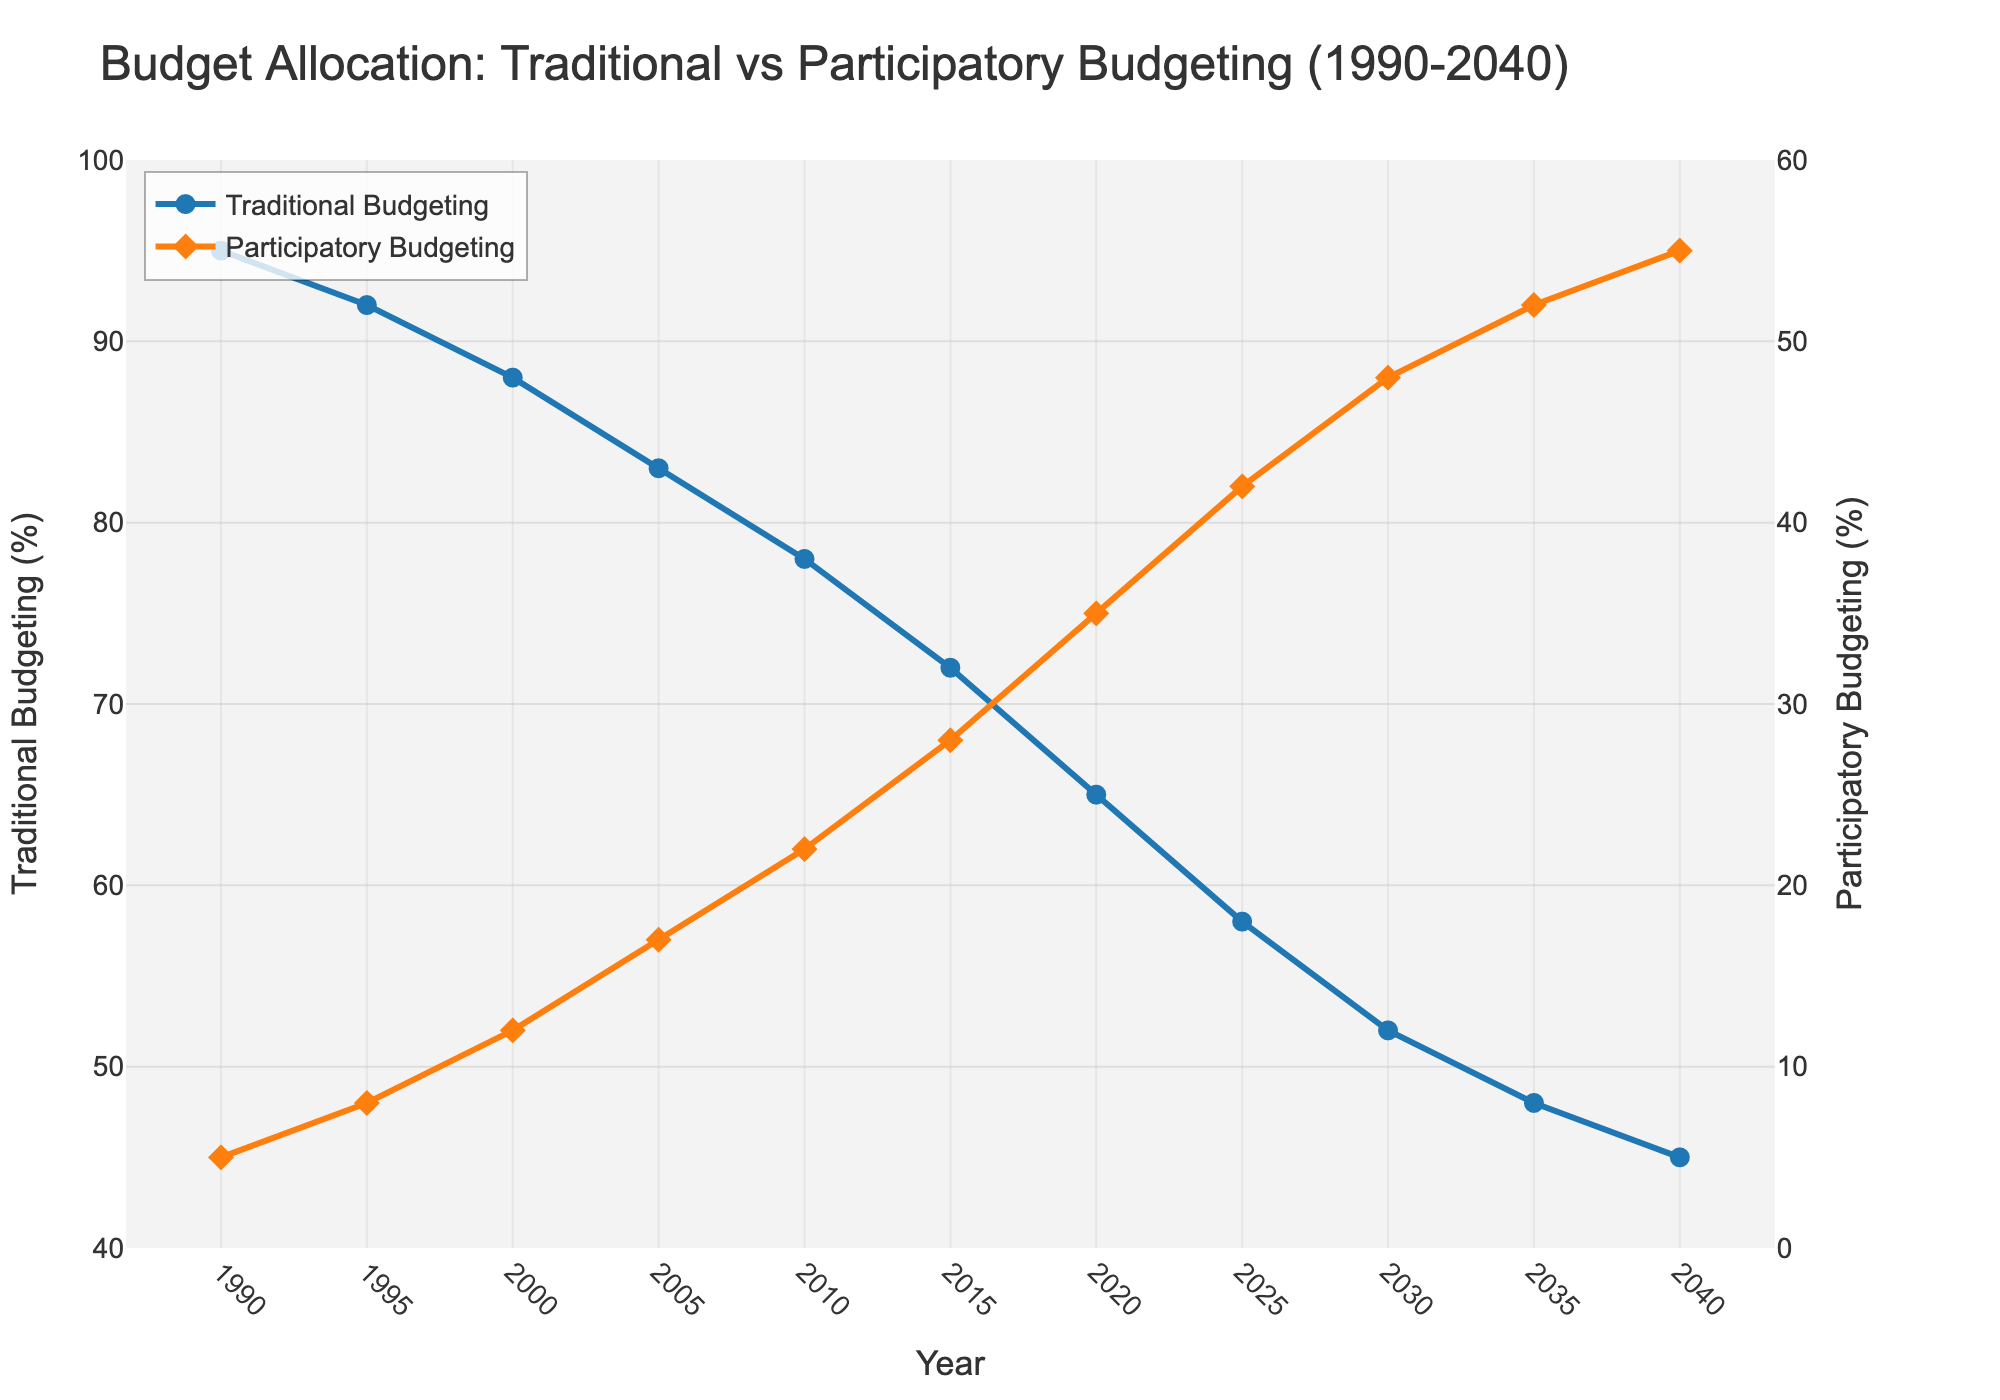How does the percentage of participatory budgeting change from 1990 to 2040? The participatory budgeting percentage increases from 5% in 1990 to 55% in 2040. Subtracting 5% from 55% gives a 50% increase over the 50-year period.
Answer: 50% Which year shows equality in budget allocation percentages between traditional and participatory budgeting? By examining the plot, we see that in 2035, both traditional and participatory budgeting percentages are 50%.
Answer: 2035 How much did the traditional budgeting allocation decrease from 2000 to 2020? Traditional budgeting was at 88% in 2000 and decreases to 65% in 2020. The difference is 88% - 65% = 23%.
Answer: 23% Between 2010 and 2015, which budgeting method saw a larger change in percentage and by how much? Participatory budgeting increased from 22% to 28% (a change of 6%), while traditional budgeting decreased from 78% to 72% (a change of 6%). Both methods saw an equal change.
Answer: Equal change, 6% What is the average percentage of participatory budgeting in the years 1990, 2000, 2010, 2020, and 2040? The percentages are 5, 12, 22, 35, and 55. Sum these up to get 5 + 12 + 22 + 35 + 55 = 129. Divide by 5 to get the average: 129 / 5 = 25.8%.
Answer: 25.8% In which year did participatory budgeting first exceed 20%? From the plot, participatory budgeting first exceeds 20% in the year 2010, where it reaches 22%.
Answer: 2010 By how much does traditional budgeting exceed participatory budgeting in 1995? Traditional budgeting is at 92% and participatory budgeting is at 8% in 1995. The difference is 92% - 8% = 84%.
Answer: 84% Compare the rate of decline in traditional budgeting percentages between the first decade (1990-2000) and the last decade (2030-2040). Which decade had a steeper decline? From 1990 to 2000, traditional budgeting decreases from 95% to 88%, a decline of 7%. From 2030 to 2040, it decreases from 52% to 45%, a decline of 7%. Both decades have the same rate of decline.
Answer: Same rate Which year's participatory budgeting value is closest to the midpoint of its range (0-60%)? The midpoint of the range 0-60% is 30%. In the year 2015, participatory budgeting has a value of 28%, which is closest to 30%.
Answer: 2015 Between the years representing 1990 and 2040, which budgeting method and year showed the highest increase in participatory budgeting percentage? Participatory budgeting increased the most in percentage points between 2025 and 2030, increasing from 42% to 48%, a 6% increase.
Answer: Participatory budgeting, 2025-2030 